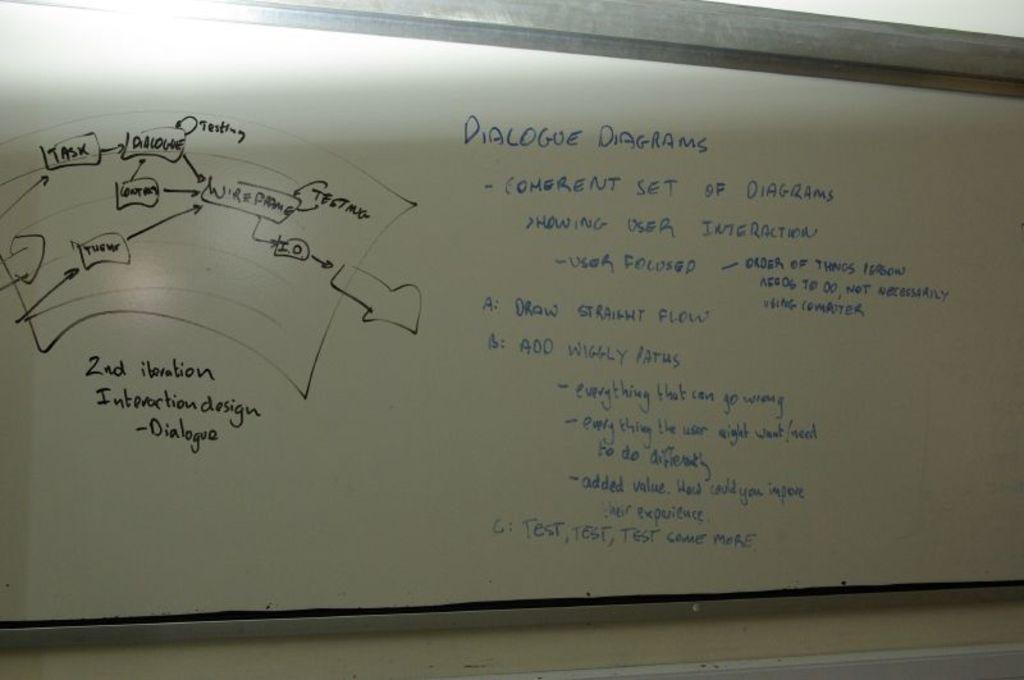<image>
Summarize the visual content of the image. A whiteboard with information and diagrams about dialogue diagrams 